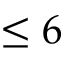Convert formula to latex. <formula><loc_0><loc_0><loc_500><loc_500>\leq 6</formula> 